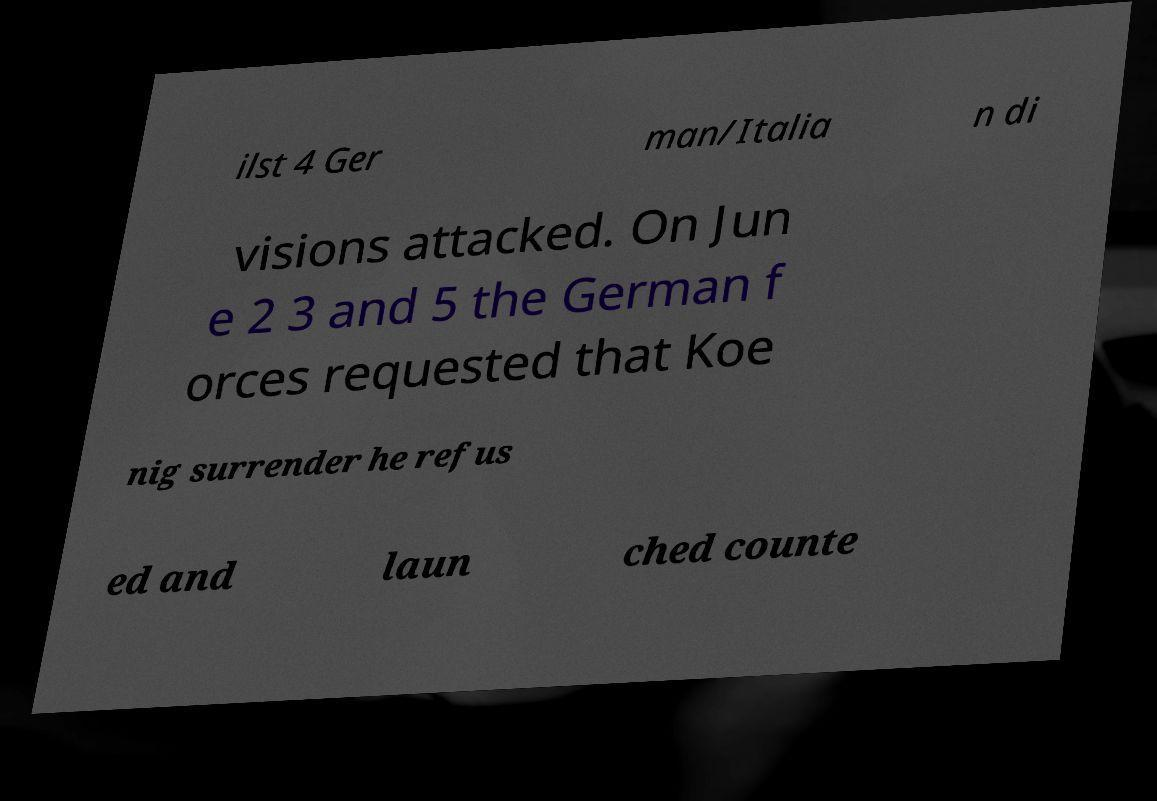For documentation purposes, I need the text within this image transcribed. Could you provide that? ilst 4 Ger man/Italia n di visions attacked. On Jun e 2 3 and 5 the German f orces requested that Koe nig surrender he refus ed and laun ched counte 